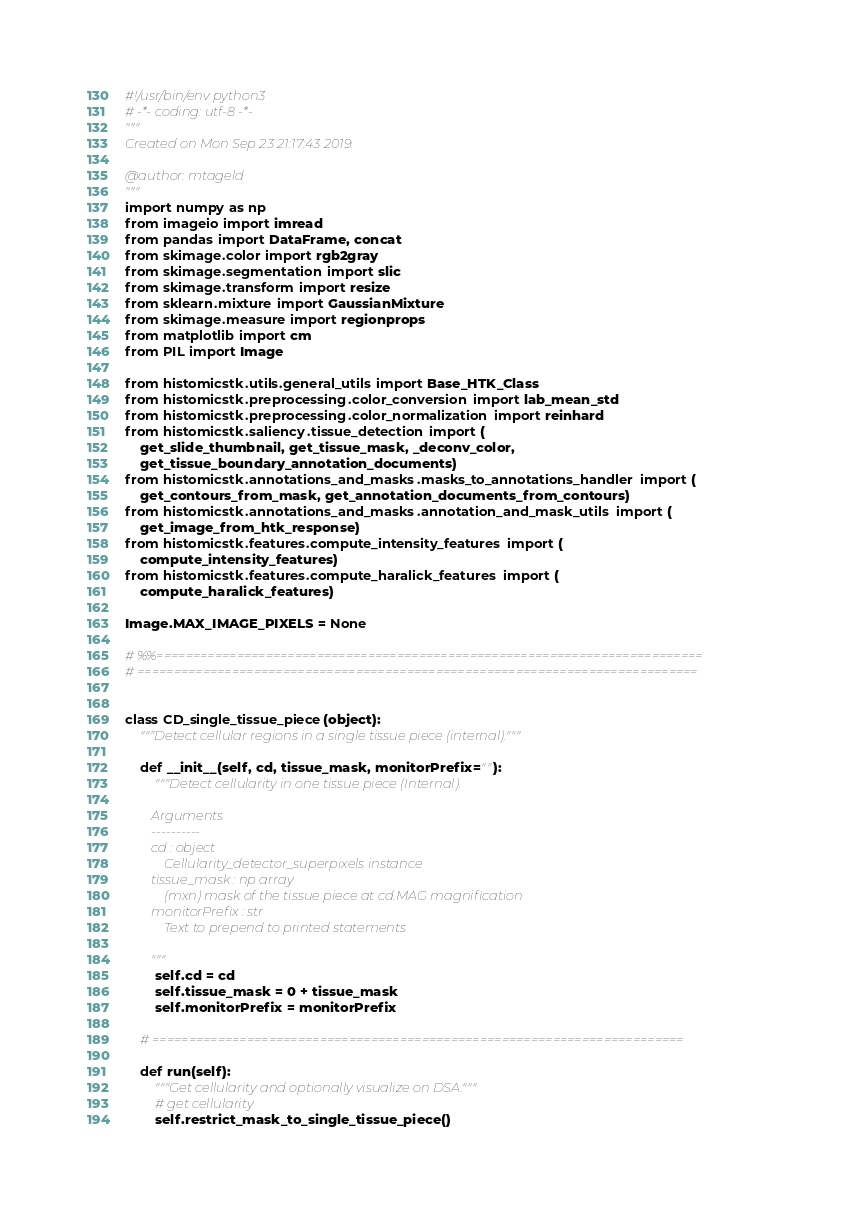<code> <loc_0><loc_0><loc_500><loc_500><_Python_>#!/usr/bin/env python3
# -*- coding: utf-8 -*-
"""
Created on Mon Sep 23 21:17:43 2019.

@author: mtageld
"""
import numpy as np
from imageio import imread
from pandas import DataFrame, concat
from skimage.color import rgb2gray
from skimage.segmentation import slic
from skimage.transform import resize
from sklearn.mixture import GaussianMixture
from skimage.measure import regionprops
from matplotlib import cm
from PIL import Image

from histomicstk.utils.general_utils import Base_HTK_Class
from histomicstk.preprocessing.color_conversion import lab_mean_std
from histomicstk.preprocessing.color_normalization import reinhard
from histomicstk.saliency.tissue_detection import (
    get_slide_thumbnail, get_tissue_mask, _deconv_color,
    get_tissue_boundary_annotation_documents)
from histomicstk.annotations_and_masks.masks_to_annotations_handler import (
    get_contours_from_mask, get_annotation_documents_from_contours)
from histomicstk.annotations_and_masks.annotation_and_mask_utils import (
    get_image_from_htk_response)
from histomicstk.features.compute_intensity_features import (
    compute_intensity_features)
from histomicstk.features.compute_haralick_features import (
    compute_haralick_features)

Image.MAX_IMAGE_PIXELS = None

# %%===========================================================================
# =============================================================================


class CD_single_tissue_piece(object):
    """Detect cellular regions in a single tissue piece (internal)."""

    def __init__(self, cd, tissue_mask, monitorPrefix=""):
        """Detect cellularity in one tissue piece (Internal).

        Arguments
        ----------
        cd : object
            Cellularity_detector_superpixels instance
        tissue_mask : np array
            (mxn) mask of the tissue piece at cd.MAG magnification
        monitorPrefix : str
            Text to prepend to printed statements

        """
        self.cd = cd
        self.tissue_mask = 0 + tissue_mask
        self.monitorPrefix = monitorPrefix

    # =========================================================================

    def run(self):
        """Get cellularity and optionally visualize on DSA."""
        # get cellularity
        self.restrict_mask_to_single_tissue_piece()</code> 